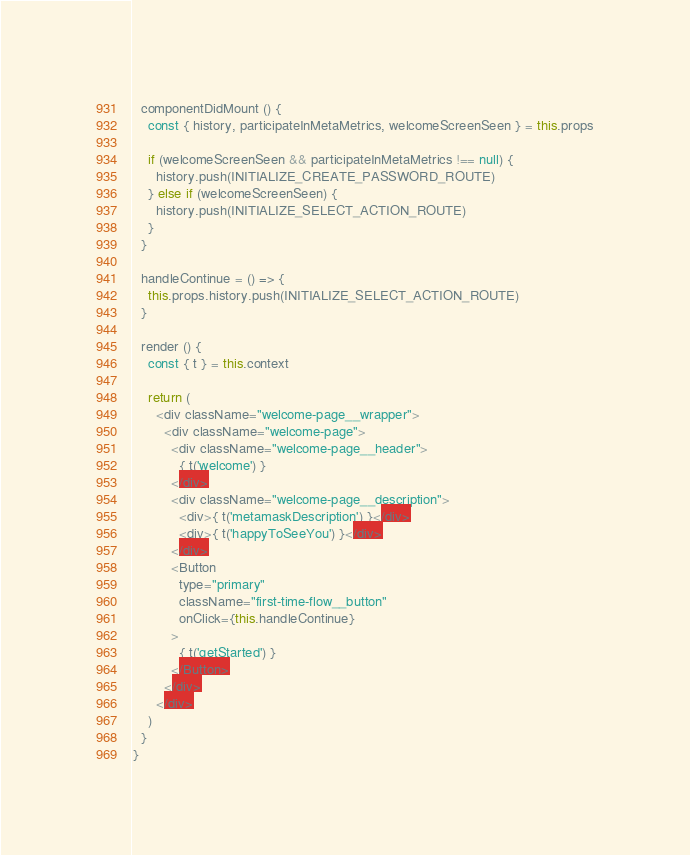<code> <loc_0><loc_0><loc_500><loc_500><_JavaScript_>  componentDidMount () {
    const { history, participateInMetaMetrics, welcomeScreenSeen } = this.props

    if (welcomeScreenSeen && participateInMetaMetrics !== null) {
      history.push(INITIALIZE_CREATE_PASSWORD_ROUTE)
    } else if (welcomeScreenSeen) {
      history.push(INITIALIZE_SELECT_ACTION_ROUTE)
    }
  }

  handleContinue = () => {
    this.props.history.push(INITIALIZE_SELECT_ACTION_ROUTE)
  }

  render () {
    const { t } = this.context

    return (
      <div className="welcome-page__wrapper">
        <div className="welcome-page">
          <div className="welcome-page__header">
            { t('welcome') }
          </div>
          <div className="welcome-page__description">
            <div>{ t('metamaskDescription') }</div>
            <div>{ t('happyToSeeYou') }</div>
          </div>
          <Button
            type="primary"
            className="first-time-flow__button"
            onClick={this.handleContinue}
          >
            { t('getStarted') }
          </Button>
        </div>
      </div>
    )
  }
}
</code> 